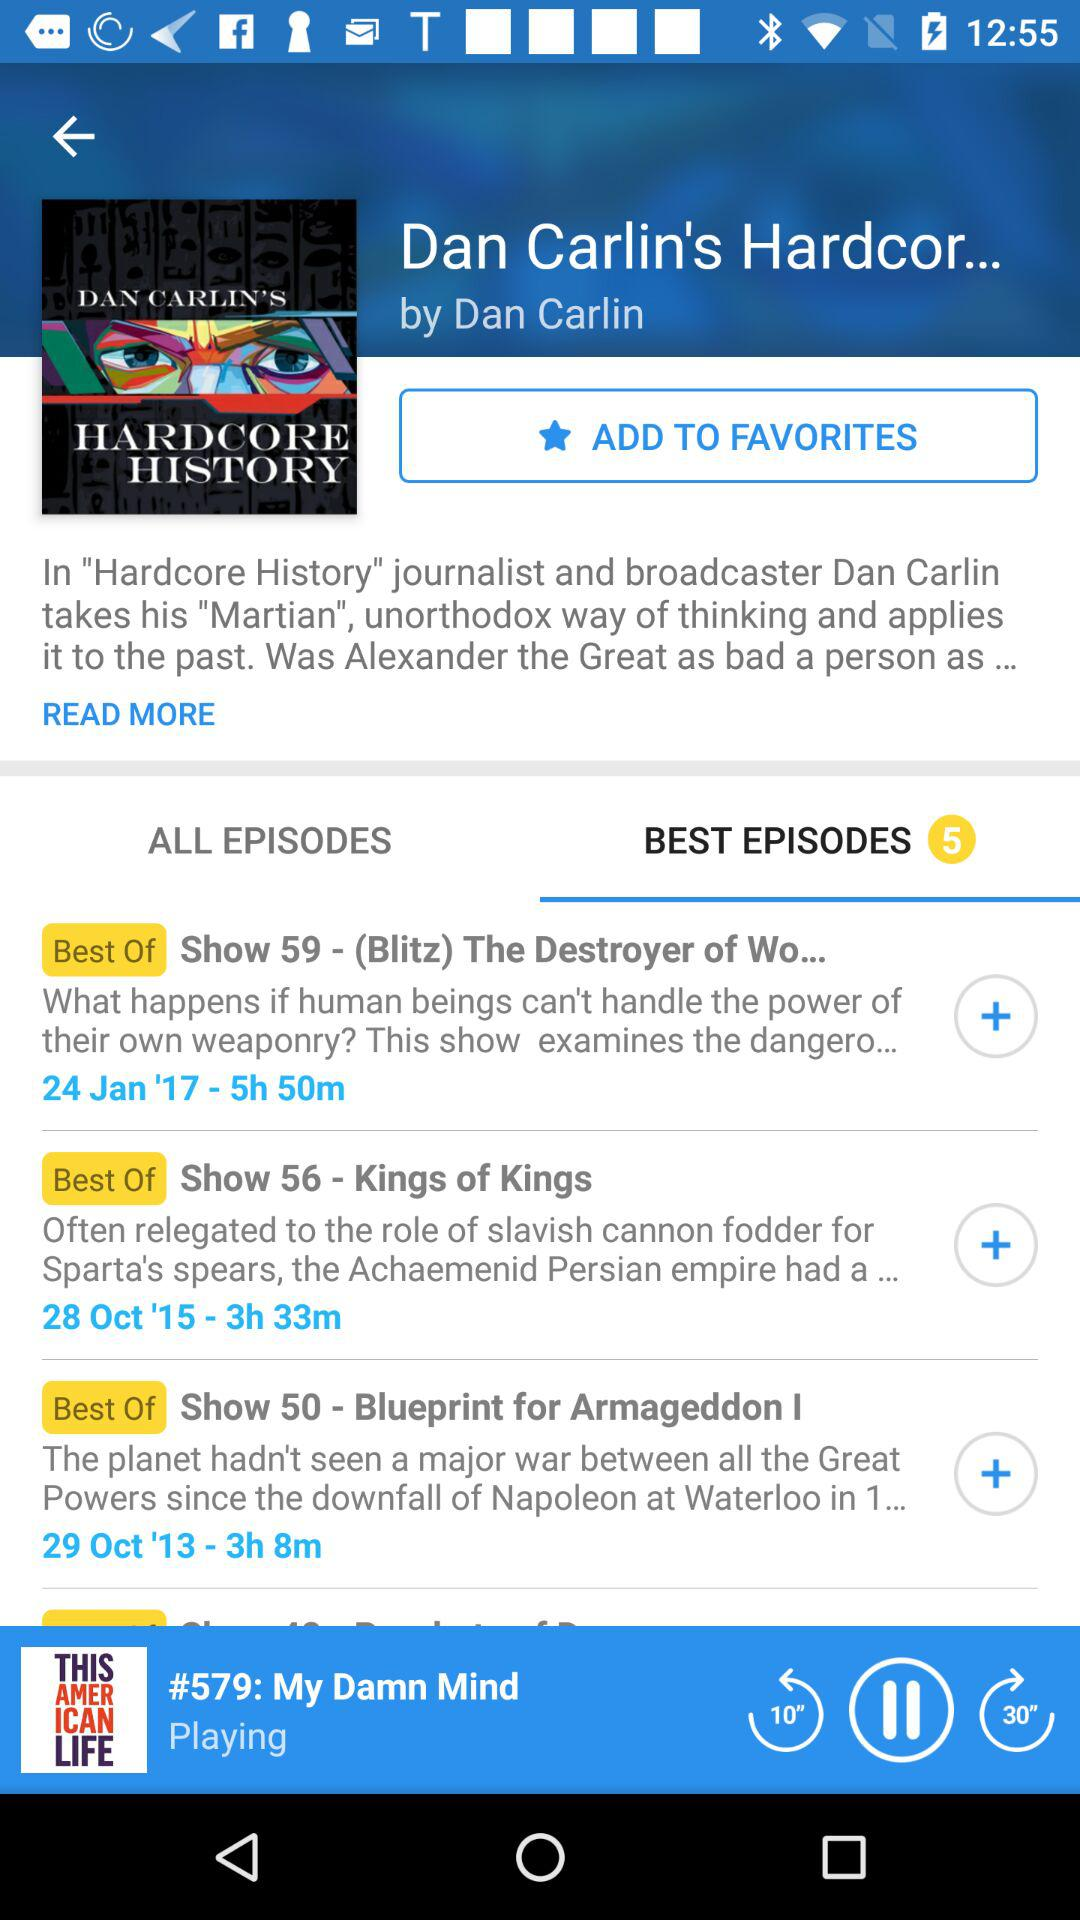What is the show number of the Blueprint for Armageddon I? The show number is 50. 